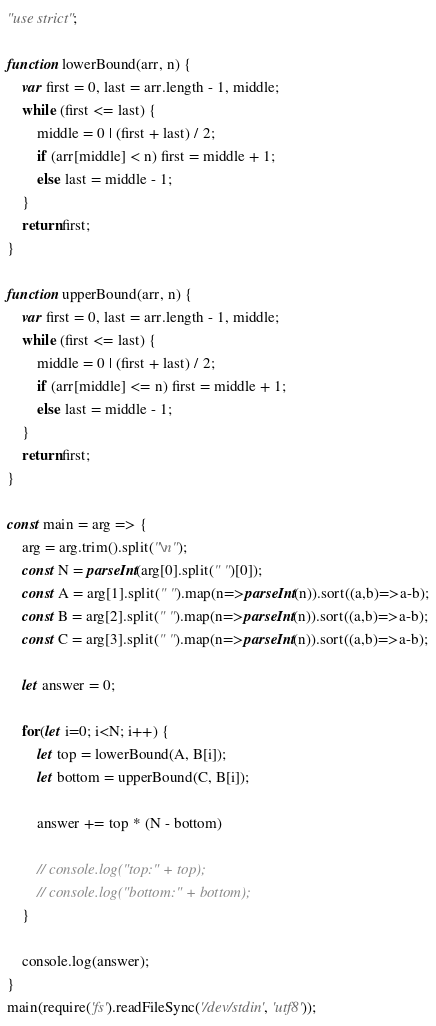Convert code to text. <code><loc_0><loc_0><loc_500><loc_500><_JavaScript_>"use strict";
    
function lowerBound(arr, n) {
    var first = 0, last = arr.length - 1, middle;
    while (first <= last) {
        middle = 0 | (first + last) / 2;
        if (arr[middle] < n) first = middle + 1;
        else last = middle - 1;
    }
    return first;
}

function upperBound(arr, n) {
    var first = 0, last = arr.length - 1, middle;
    while (first <= last) {
        middle = 0 | (first + last) / 2;
        if (arr[middle] <= n) first = middle + 1;
        else last = middle - 1;
    }
    return first;
}

const main = arg => {
    arg = arg.trim().split("\n");
    const N = parseInt(arg[0].split(" ")[0]);
    const A = arg[1].split(" ").map(n=>parseInt(n)).sort((a,b)=>a-b);
    const B = arg[2].split(" ").map(n=>parseInt(n)).sort((a,b)=>a-b);
    const C = arg[3].split(" ").map(n=>parseInt(n)).sort((a,b)=>a-b);
    
    let answer = 0;
    
    for(let i=0; i<N; i++) {
        let top = lowerBound(A, B[i]);
        let bottom = upperBound(C, B[i]);
        
        answer += top * (N - bottom)
        
        // console.log("top:" + top);
        // console.log("bottom:" + bottom);
    }
    
    console.log(answer);
}
main(require('fs').readFileSync('/dev/stdin', 'utf8'));</code> 